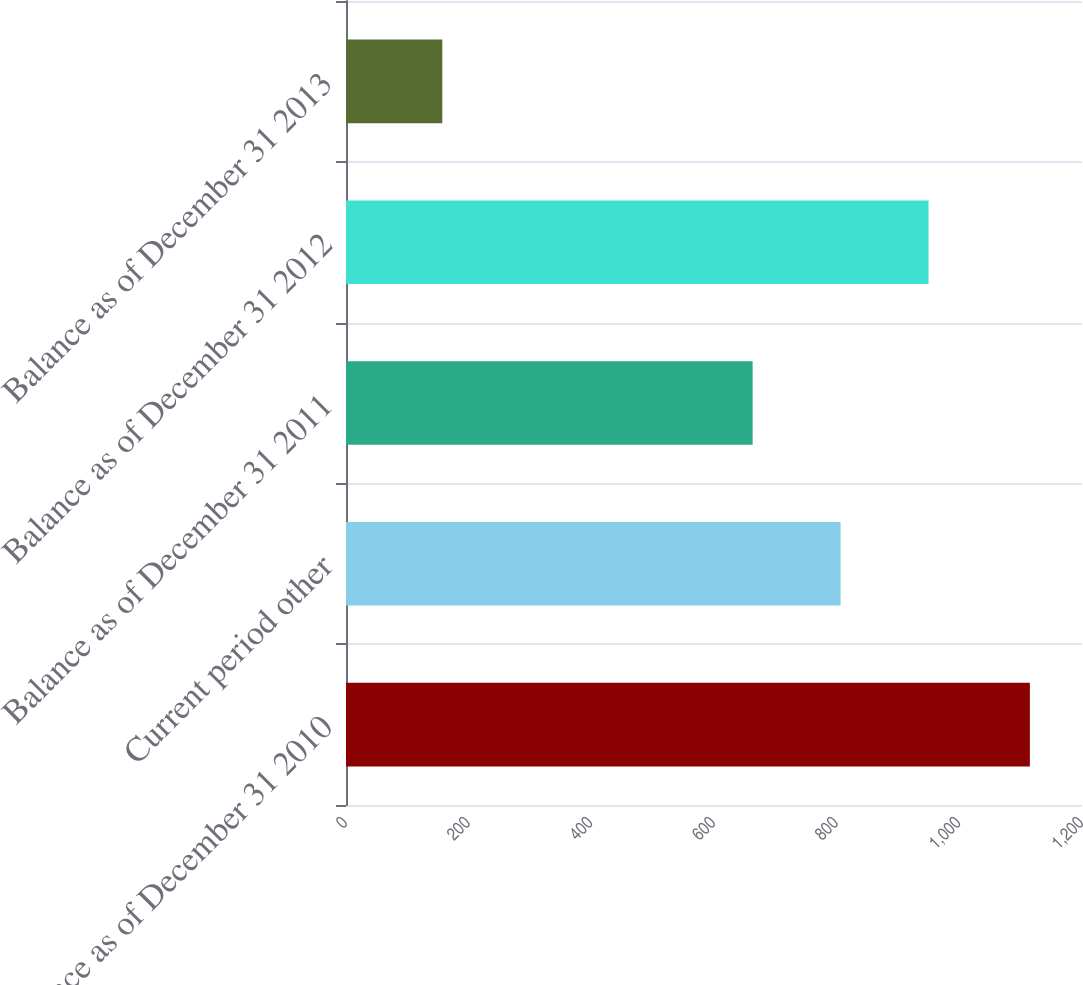Convert chart to OTSL. <chart><loc_0><loc_0><loc_500><loc_500><bar_chart><fcel>Balance as of December 31 2010<fcel>Current period other<fcel>Balance as of December 31 2011<fcel>Balance as of December 31 2012<fcel>Balance as of December 31 2013<nl><fcel>1115<fcel>806.4<fcel>663<fcel>949.8<fcel>157<nl></chart> 